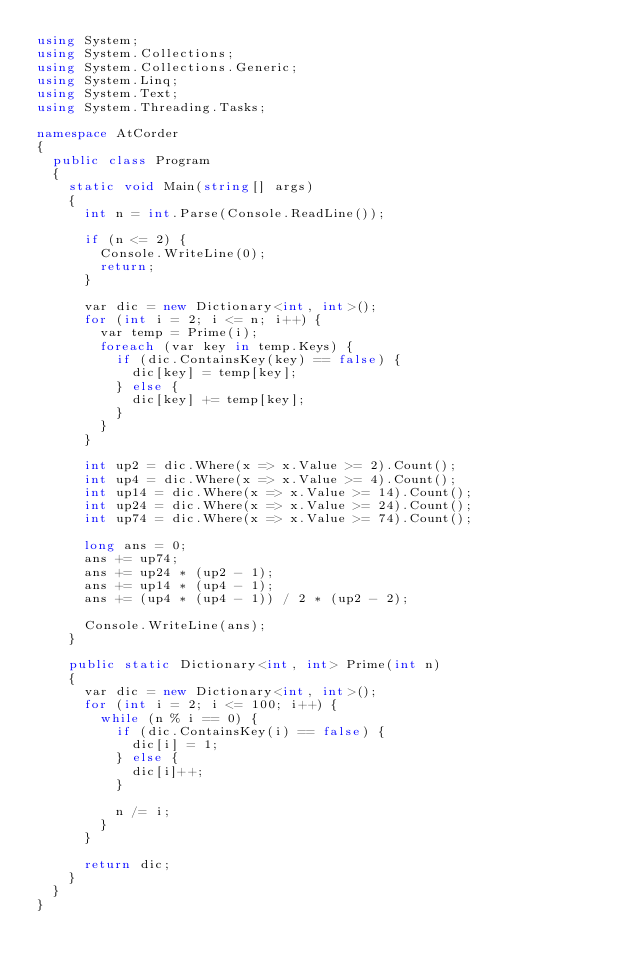Convert code to text. <code><loc_0><loc_0><loc_500><loc_500><_C#_>using System;
using System.Collections;
using System.Collections.Generic;
using System.Linq;
using System.Text;
using System.Threading.Tasks;

namespace AtCorder
{
	public class Program
	{
		static void Main(string[] args)
		{
			int n = int.Parse(Console.ReadLine());

			if (n <= 2) {
				Console.WriteLine(0);
				return;
			}

			var dic = new Dictionary<int, int>();
			for (int i = 2; i <= n; i++) {
				var temp = Prime(i);
				foreach (var key in temp.Keys) {
					if (dic.ContainsKey(key) == false) {
						dic[key] = temp[key];
					} else {
						dic[key] += temp[key];
					}
				}
			}

			int up2 = dic.Where(x => x.Value >= 2).Count();
			int up4 = dic.Where(x => x.Value >= 4).Count();
			int up14 = dic.Where(x => x.Value >= 14).Count();
			int up24 = dic.Where(x => x.Value >= 24).Count();
			int up74 = dic.Where(x => x.Value >= 74).Count();

			long ans = 0;
			ans += up74;
			ans += up24 * (up2 - 1);
			ans += up14 * (up4 - 1);
			ans += (up4 * (up4 - 1)) / 2 * (up2 - 2);

			Console.WriteLine(ans);
		}

		public static Dictionary<int, int> Prime(int n)
		{
			var dic = new Dictionary<int, int>();
			for (int i = 2; i <= 100; i++) {
				while (n % i == 0) {
					if (dic.ContainsKey(i) == false) {
						dic[i] = 1;
					} else {
						dic[i]++;
					}

					n /= i;
				}
			}

			return dic;
		}
	}
}</code> 